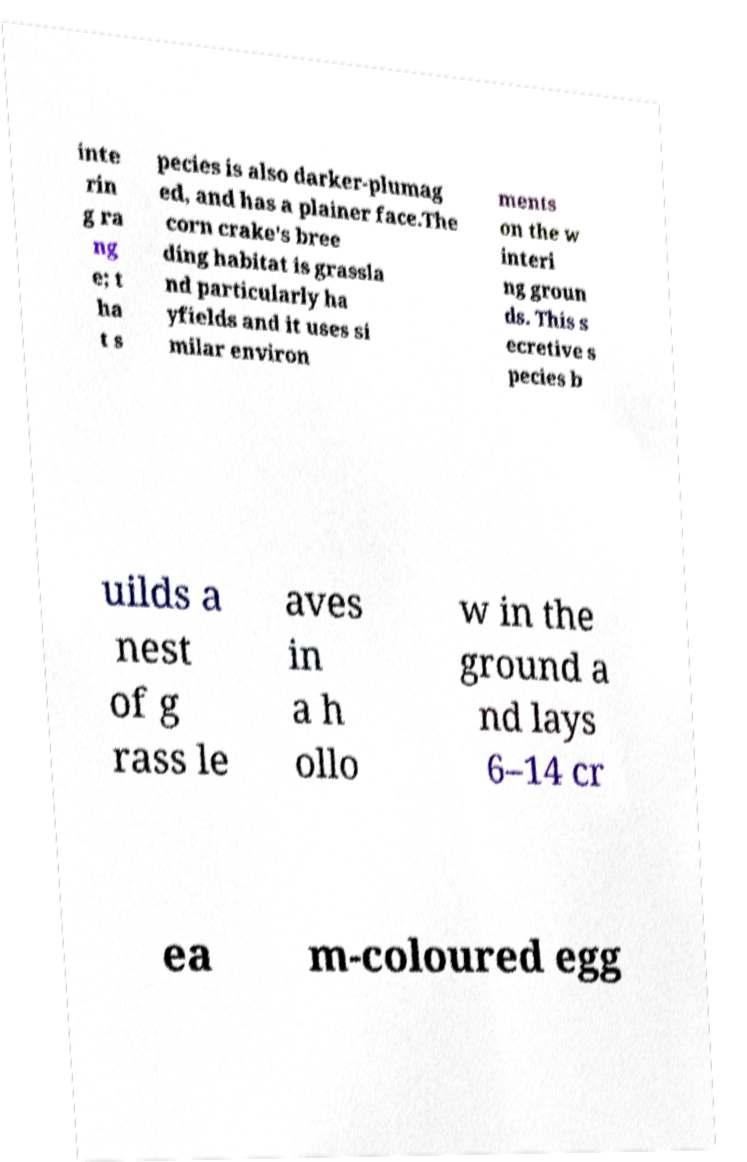For documentation purposes, I need the text within this image transcribed. Could you provide that? inte rin g ra ng e; t ha t s pecies is also darker-plumag ed, and has a plainer face.The corn crake's bree ding habitat is grassla nd particularly ha yfields and it uses si milar environ ments on the w interi ng groun ds. This s ecretive s pecies b uilds a nest of g rass le aves in a h ollo w in the ground a nd lays 6–14 cr ea m-coloured egg 